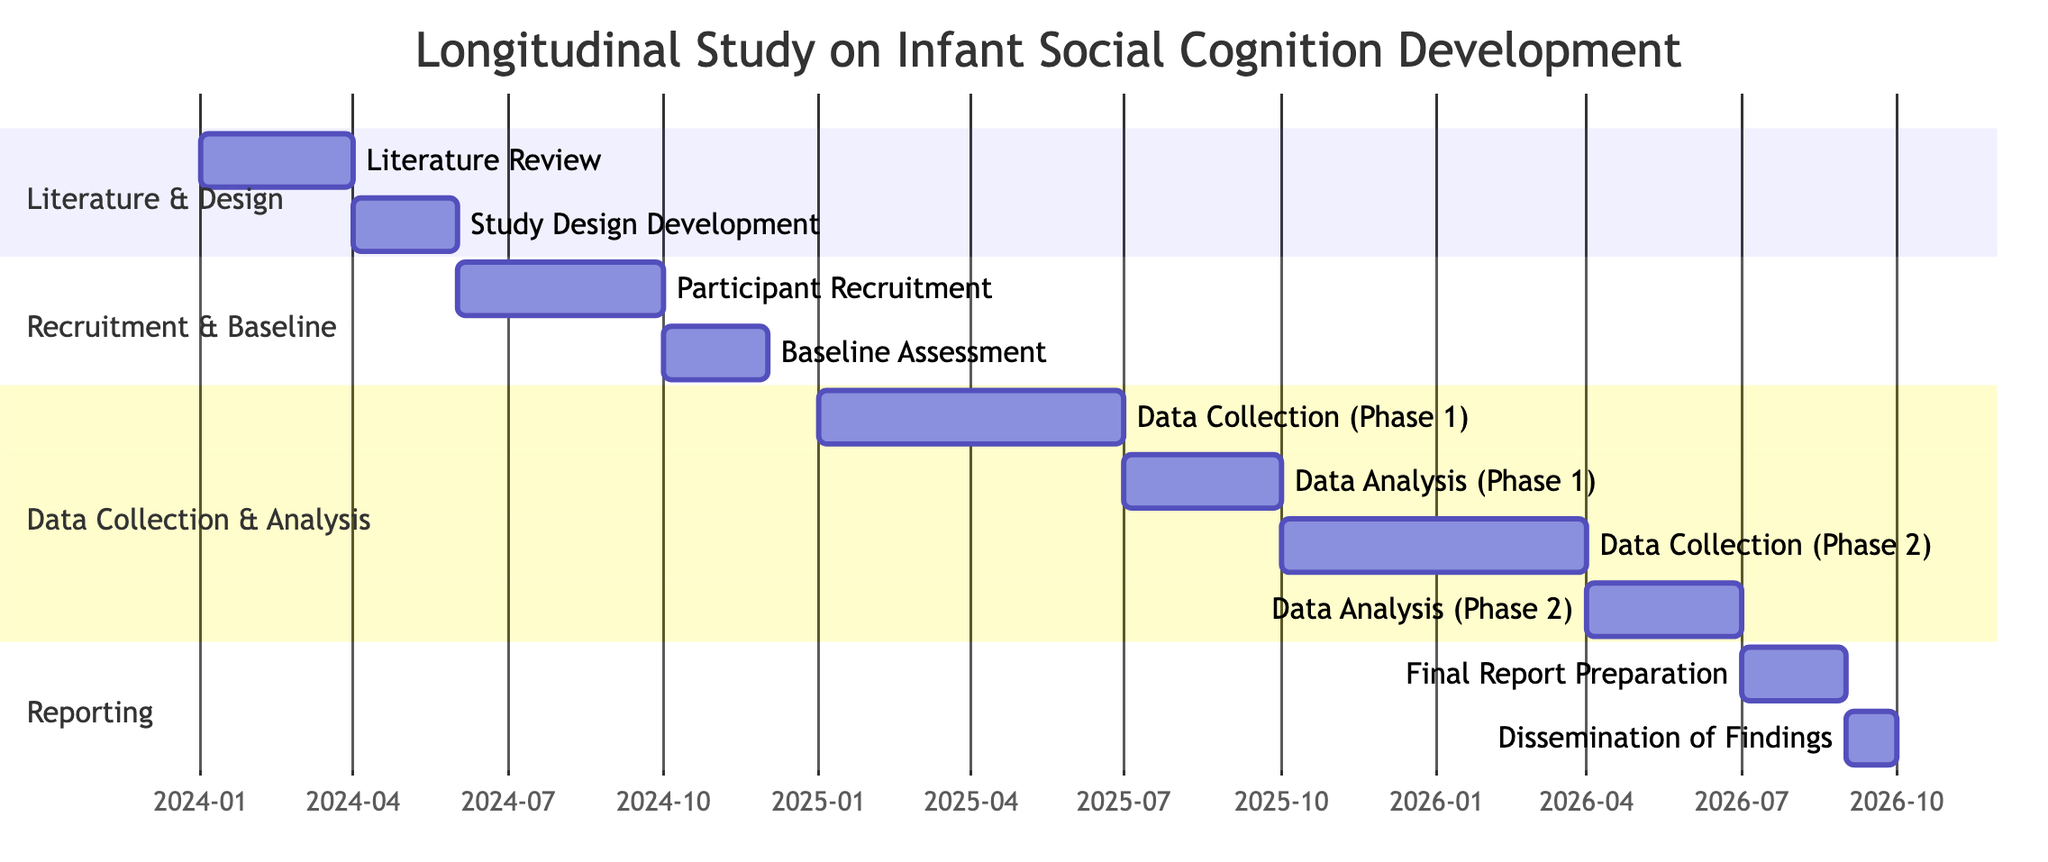What is the duration of the Literature Review phase? The Literature Review phase is explicitly stated as lasting for 3 months, as indicated in the diagram.
Answer: 3 months What are the start and end dates for Participant Recruitment? The diagram shows that Participant Recruitment starts on June 1, 2024, and ends on September 30, 2024.
Answer: June 1, 2024 - September 30, 2024 How many phases are related to data collection in the study? By inspecting the diagram, there are two data collection phases: Data Collection (Phase 1) and Data Collection (Phase 2).
Answer: 2 What is the total duration of the data analysis phases? The diagram shows that Data Analysis (Phase 1) lasts for 3 months and Data Analysis (Phase 2) also lasts for 3 months. Adding these gives a total duration of 6 months.
Answer: 6 months Which phase follows the Baseline Assessment? The diagram clearly indicates that Data Collection (Phase 1) follows the Baseline Assessment, occurring directly thereafter.
Answer: Data Collection (Phase 1) What is the gap between the end of the Data Collection (Phase 1) and the start of the Data Analysis (Phase 1)? Data Collection (Phase 1) ends on June 30, 2025, and Data Analysis (Phase 1) starts on July 1, 2025, showing no gap in between these phases.
Answer: No gap In which section does the Final Report Preparation phase appear? The diagram delineates phases into sections, and Final Report Preparation is placed in the Reporting section.
Answer: Reporting What is the earliest start date for any phase in the study? The earliest start date is shown in the diagram as January 1, 2024, which is when the Literature Review begins.
Answer: January 1, 2024 How long after the Baseline Assessment does Data Collection (Phase 2) begin? The Baseline Assessment ends on November 30, 2024, and Data Collection (Phase 2) starts on October 1, 2025, indicating a gap of 10 months between these two phases.
Answer: 10 months 